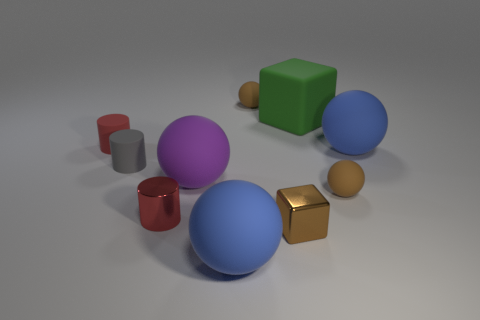Subtract all purple balls. How many balls are left? 4 Subtract all large purple rubber spheres. How many spheres are left? 4 Subtract all yellow balls. Subtract all green cylinders. How many balls are left? 5 Subtract all cubes. How many objects are left? 8 Add 3 green matte blocks. How many green matte blocks are left? 4 Add 4 large blocks. How many large blocks exist? 5 Subtract 0 red spheres. How many objects are left? 10 Subtract all yellow cylinders. Subtract all tiny rubber objects. How many objects are left? 6 